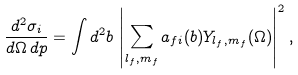<formula> <loc_0><loc_0><loc_500><loc_500>\frac { d ^ { 2 } \sigma _ { i } } { d \Omega \, d p } = \int d ^ { 2 } b \, \left | \sum _ { l _ { f } , m _ { f } } a _ { f i } ( b ) Y _ { l _ { f } , m _ { f } } ( \Omega ) \right | ^ { 2 } ,</formula> 